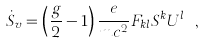Convert formula to latex. <formula><loc_0><loc_0><loc_500><loc_500>\dot { S } _ { v } = \left ( \frac { g } { 2 } - 1 \right ) \frac { e } { m c ^ { 2 } } F _ { k l } S ^ { k } U ^ { l } \ ,</formula> 